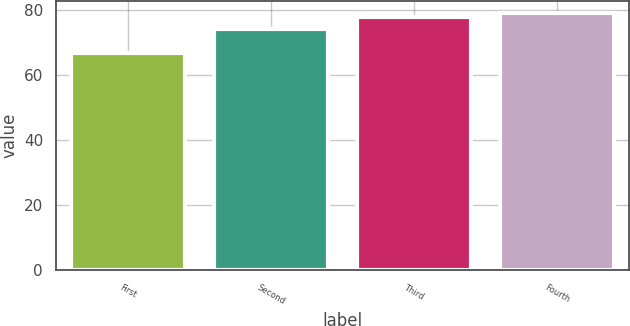<chart> <loc_0><loc_0><loc_500><loc_500><bar_chart><fcel>First<fcel>Second<fcel>Third<fcel>Fourth<nl><fcel>66.93<fcel>74.19<fcel>77.93<fcel>79.07<nl></chart> 